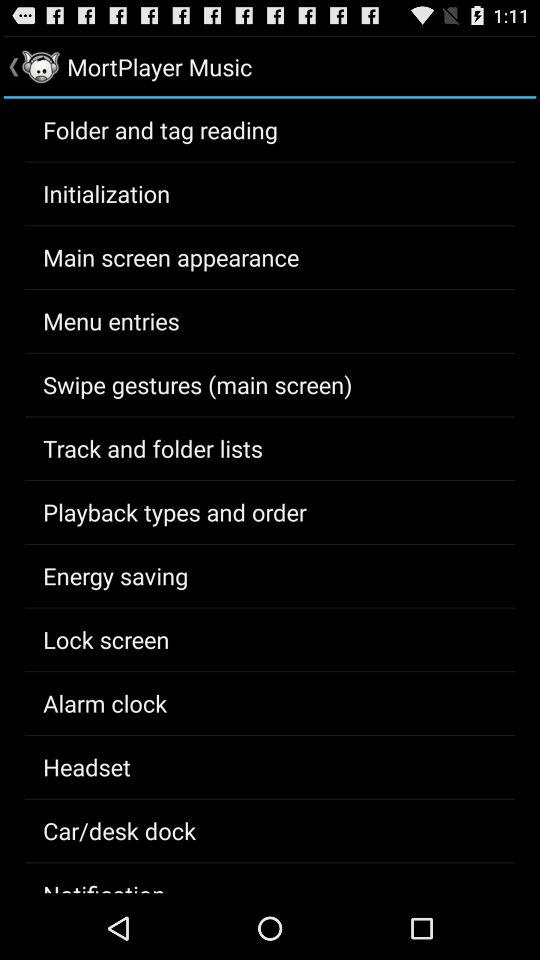What is the application name? The application name is "MortPlayer Music". 